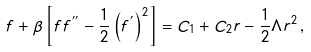Convert formula to latex. <formula><loc_0><loc_0><loc_500><loc_500>f + \beta \left [ f f ^ { ^ { \prime \prime } } - \frac { 1 } { 2 } \left ( f ^ { ^ { \prime } } \right ) ^ { 2 } \right ] = C _ { 1 } + C _ { 2 } r - \frac { 1 } { 2 } \Lambda r ^ { 2 } \, ,</formula> 